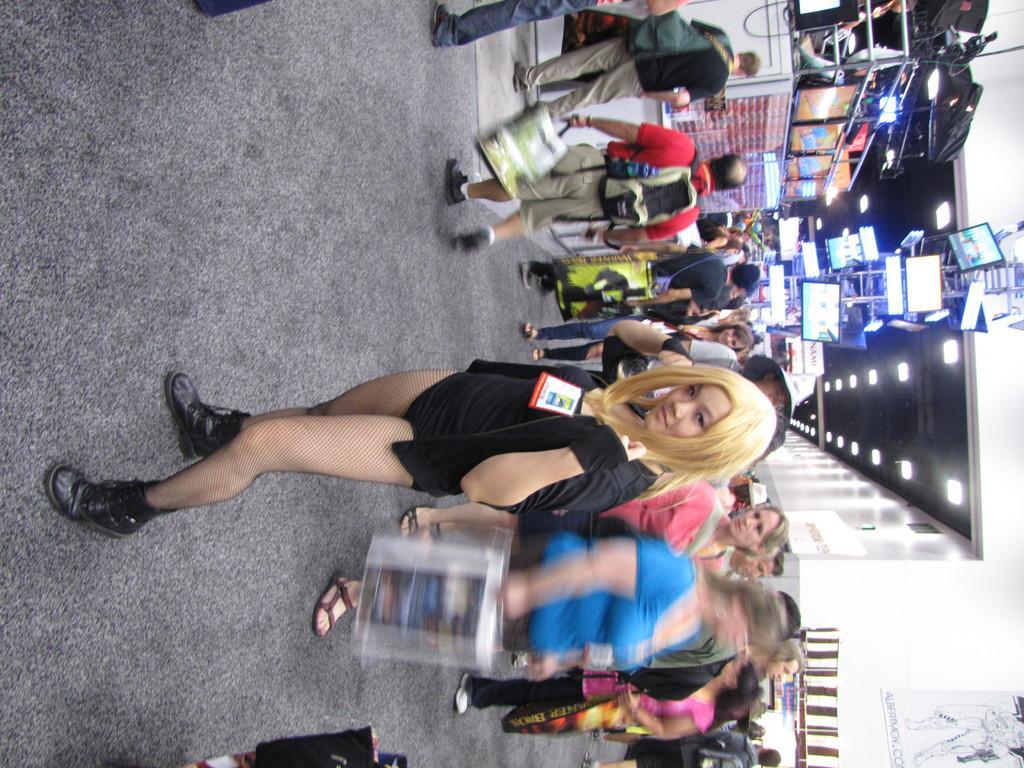Please provide a concise description of this image. This is a woman standing. She wore a black dress and shoes. I can see groups of people walking. I think these are the boards, which are attached to a pole. I can see the ceiling lights. This looks like a poster, which is attached to the wall. I think this is a kind of a tent. 